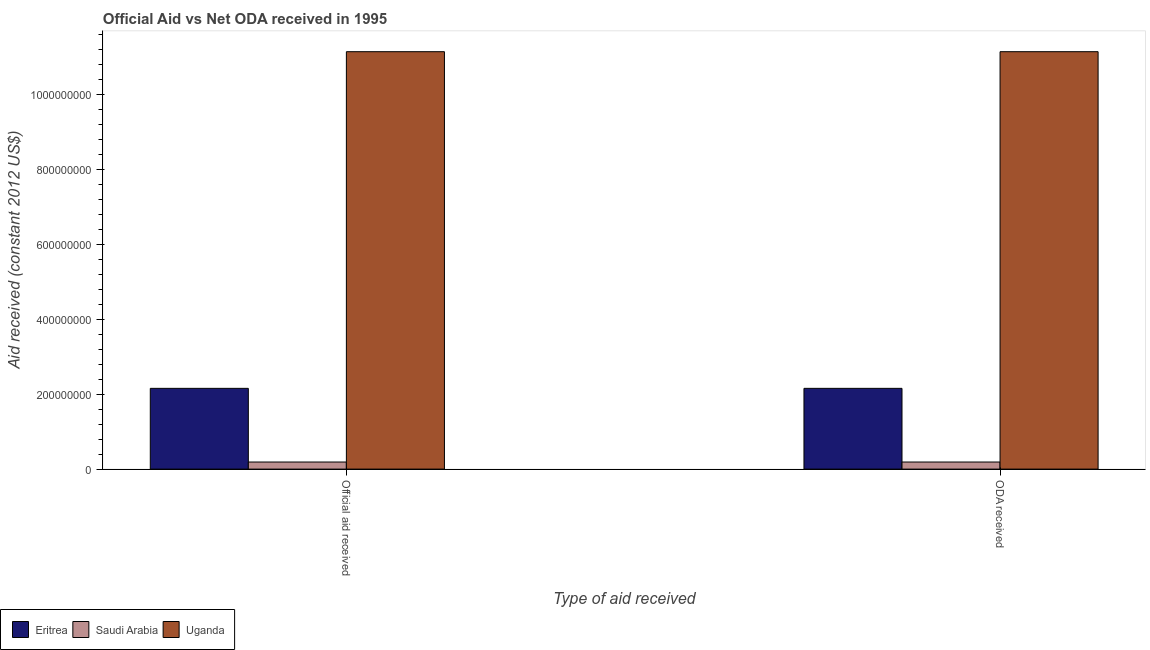Are the number of bars on each tick of the X-axis equal?
Offer a very short reply. Yes. How many bars are there on the 2nd tick from the right?
Your answer should be compact. 3. What is the label of the 2nd group of bars from the left?
Ensure brevity in your answer.  ODA received. What is the official aid received in Uganda?
Ensure brevity in your answer.  1.11e+09. Across all countries, what is the maximum official aid received?
Make the answer very short. 1.11e+09. Across all countries, what is the minimum official aid received?
Offer a terse response. 1.89e+07. In which country was the official aid received maximum?
Your answer should be very brief. Uganda. In which country was the official aid received minimum?
Keep it short and to the point. Saudi Arabia. What is the total official aid received in the graph?
Provide a short and direct response. 1.35e+09. What is the difference between the oda received in Uganda and that in Saudi Arabia?
Your answer should be very brief. 1.09e+09. What is the difference between the official aid received in Uganda and the oda received in Saudi Arabia?
Offer a very short reply. 1.09e+09. What is the average official aid received per country?
Your answer should be very brief. 4.49e+08. What is the difference between the official aid received and oda received in Eritrea?
Offer a terse response. 0. In how many countries, is the official aid received greater than 1040000000 US$?
Ensure brevity in your answer.  1. What is the ratio of the official aid received in Saudi Arabia to that in Uganda?
Keep it short and to the point. 0.02. Is the oda received in Eritrea less than that in Saudi Arabia?
Your answer should be compact. No. What does the 1st bar from the left in ODA received represents?
Offer a terse response. Eritrea. What does the 1st bar from the right in Official aid received represents?
Offer a very short reply. Uganda. How many countries are there in the graph?
Your answer should be compact. 3. Are the values on the major ticks of Y-axis written in scientific E-notation?
Offer a very short reply. No. Where does the legend appear in the graph?
Make the answer very short. Bottom left. What is the title of the graph?
Offer a terse response. Official Aid vs Net ODA received in 1995 . Does "Haiti" appear as one of the legend labels in the graph?
Ensure brevity in your answer.  No. What is the label or title of the X-axis?
Keep it short and to the point. Type of aid received. What is the label or title of the Y-axis?
Your answer should be very brief. Aid received (constant 2012 US$). What is the Aid received (constant 2012 US$) of Eritrea in Official aid received?
Offer a terse response. 2.15e+08. What is the Aid received (constant 2012 US$) in Saudi Arabia in Official aid received?
Provide a short and direct response. 1.89e+07. What is the Aid received (constant 2012 US$) of Uganda in Official aid received?
Keep it short and to the point. 1.11e+09. What is the Aid received (constant 2012 US$) in Eritrea in ODA received?
Make the answer very short. 2.15e+08. What is the Aid received (constant 2012 US$) in Saudi Arabia in ODA received?
Give a very brief answer. 1.89e+07. What is the Aid received (constant 2012 US$) in Uganda in ODA received?
Your answer should be compact. 1.11e+09. Across all Type of aid received, what is the maximum Aid received (constant 2012 US$) in Eritrea?
Give a very brief answer. 2.15e+08. Across all Type of aid received, what is the maximum Aid received (constant 2012 US$) of Saudi Arabia?
Offer a very short reply. 1.89e+07. Across all Type of aid received, what is the maximum Aid received (constant 2012 US$) of Uganda?
Give a very brief answer. 1.11e+09. Across all Type of aid received, what is the minimum Aid received (constant 2012 US$) in Eritrea?
Provide a short and direct response. 2.15e+08. Across all Type of aid received, what is the minimum Aid received (constant 2012 US$) in Saudi Arabia?
Your answer should be very brief. 1.89e+07. Across all Type of aid received, what is the minimum Aid received (constant 2012 US$) of Uganda?
Offer a very short reply. 1.11e+09. What is the total Aid received (constant 2012 US$) of Eritrea in the graph?
Ensure brevity in your answer.  4.31e+08. What is the total Aid received (constant 2012 US$) in Saudi Arabia in the graph?
Your answer should be very brief. 3.78e+07. What is the total Aid received (constant 2012 US$) in Uganda in the graph?
Make the answer very short. 2.23e+09. What is the difference between the Aid received (constant 2012 US$) of Uganda in Official aid received and that in ODA received?
Provide a succinct answer. 0. What is the difference between the Aid received (constant 2012 US$) of Eritrea in Official aid received and the Aid received (constant 2012 US$) of Saudi Arabia in ODA received?
Your answer should be very brief. 1.96e+08. What is the difference between the Aid received (constant 2012 US$) of Eritrea in Official aid received and the Aid received (constant 2012 US$) of Uganda in ODA received?
Keep it short and to the point. -8.98e+08. What is the difference between the Aid received (constant 2012 US$) in Saudi Arabia in Official aid received and the Aid received (constant 2012 US$) in Uganda in ODA received?
Your answer should be compact. -1.09e+09. What is the average Aid received (constant 2012 US$) in Eritrea per Type of aid received?
Provide a short and direct response. 2.15e+08. What is the average Aid received (constant 2012 US$) of Saudi Arabia per Type of aid received?
Your answer should be compact. 1.89e+07. What is the average Aid received (constant 2012 US$) in Uganda per Type of aid received?
Your answer should be very brief. 1.11e+09. What is the difference between the Aid received (constant 2012 US$) of Eritrea and Aid received (constant 2012 US$) of Saudi Arabia in Official aid received?
Your response must be concise. 1.96e+08. What is the difference between the Aid received (constant 2012 US$) of Eritrea and Aid received (constant 2012 US$) of Uganda in Official aid received?
Offer a very short reply. -8.98e+08. What is the difference between the Aid received (constant 2012 US$) of Saudi Arabia and Aid received (constant 2012 US$) of Uganda in Official aid received?
Offer a very short reply. -1.09e+09. What is the difference between the Aid received (constant 2012 US$) in Eritrea and Aid received (constant 2012 US$) in Saudi Arabia in ODA received?
Your answer should be compact. 1.96e+08. What is the difference between the Aid received (constant 2012 US$) in Eritrea and Aid received (constant 2012 US$) in Uganda in ODA received?
Provide a short and direct response. -8.98e+08. What is the difference between the Aid received (constant 2012 US$) of Saudi Arabia and Aid received (constant 2012 US$) of Uganda in ODA received?
Offer a very short reply. -1.09e+09. What is the difference between the highest and the second highest Aid received (constant 2012 US$) of Eritrea?
Give a very brief answer. 0. What is the difference between the highest and the second highest Aid received (constant 2012 US$) in Saudi Arabia?
Offer a terse response. 0. What is the difference between the highest and the second highest Aid received (constant 2012 US$) in Uganda?
Ensure brevity in your answer.  0. What is the difference between the highest and the lowest Aid received (constant 2012 US$) in Eritrea?
Your answer should be compact. 0. What is the difference between the highest and the lowest Aid received (constant 2012 US$) of Uganda?
Offer a very short reply. 0. 